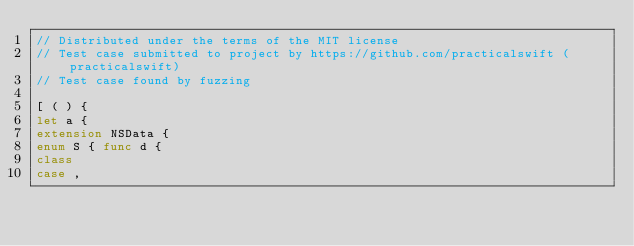<code> <loc_0><loc_0><loc_500><loc_500><_Swift_>// Distributed under the terms of the MIT license
// Test case submitted to project by https://github.com/practicalswift (practicalswift)
// Test case found by fuzzing

[ ( ) {
let a {
extension NSData {
enum S { func d {
class
case ,
</code> 